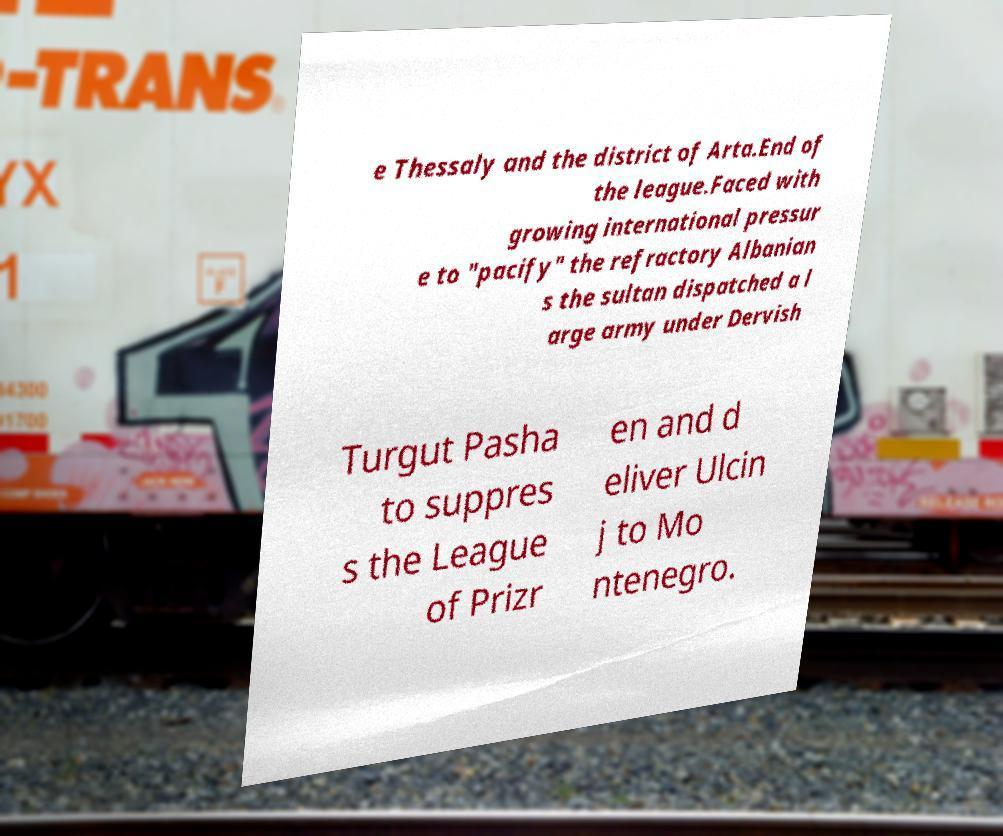Could you assist in decoding the text presented in this image and type it out clearly? e Thessaly and the district of Arta.End of the league.Faced with growing international pressur e to "pacify" the refractory Albanian s the sultan dispatched a l arge army under Dervish Turgut Pasha to suppres s the League of Prizr en and d eliver Ulcin j to Mo ntenegro. 